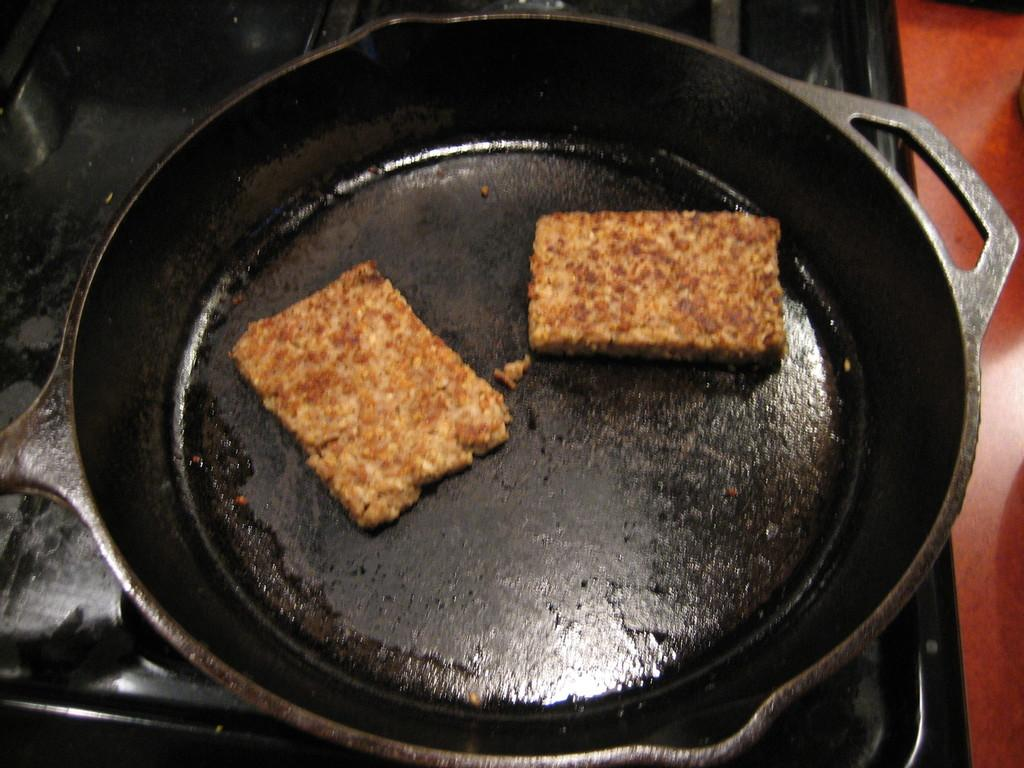What is the main subject of the image? The main subject of the image is two pieces of a food item. Where are the food items located? The food items are on a pan. What is the pan placed on? The pan is on a stove. What type of door can be seen in the image? There is no door present in the image. How many times does the person pull the food item in the image? There is no person or action of pulling in the image; it only shows two pieces of a food item on a pan on a stove. 